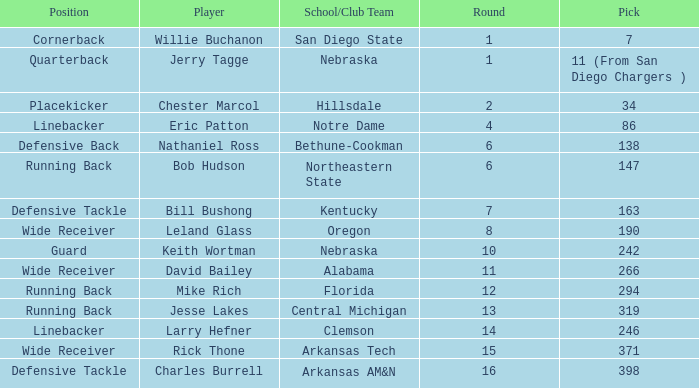Write the full table. {'header': ['Position', 'Player', 'School/Club Team', 'Round', 'Pick'], 'rows': [['Cornerback', 'Willie Buchanon', 'San Diego State', '1', '7'], ['Quarterback', 'Jerry Tagge', 'Nebraska', '1', '11 (From San Diego Chargers )'], ['Placekicker', 'Chester Marcol', 'Hillsdale', '2', '34'], ['Linebacker', 'Eric Patton', 'Notre Dame', '4', '86'], ['Defensive Back', 'Nathaniel Ross', 'Bethune-Cookman', '6', '138'], ['Running Back', 'Bob Hudson', 'Northeastern State', '6', '147'], ['Defensive Tackle', 'Bill Bushong', 'Kentucky', '7', '163'], ['Wide Receiver', 'Leland Glass', 'Oregon', '8', '190'], ['Guard', 'Keith Wortman', 'Nebraska', '10', '242'], ['Wide Receiver', 'David Bailey', 'Alabama', '11', '266'], ['Running Back', 'Mike Rich', 'Florida', '12', '294'], ['Running Back', 'Jesse Lakes', 'Central Michigan', '13', '319'], ['Linebacker', 'Larry Hefner', 'Clemson', '14', '246'], ['Wide Receiver', 'Rick Thone', 'Arkansas Tech', '15', '371'], ['Defensive Tackle', 'Charles Burrell', 'Arkansas AM&N', '16', '398']]} Which pick has a school/club team that is kentucky? 163.0. 